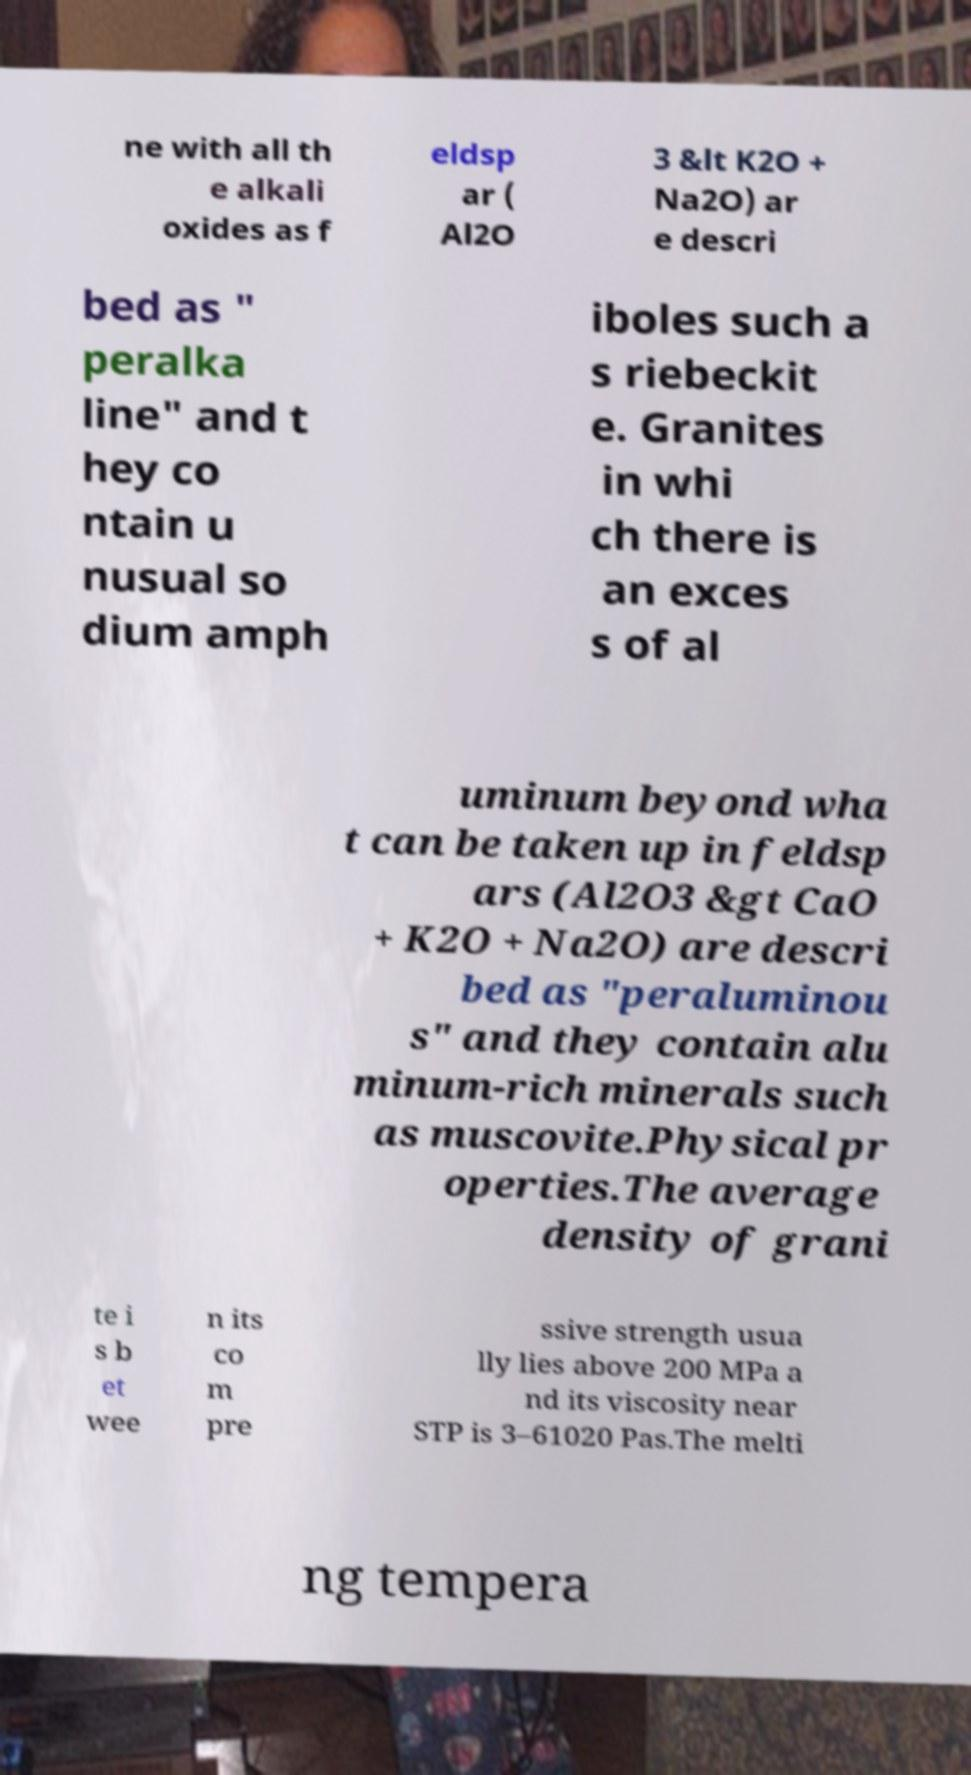I need the written content from this picture converted into text. Can you do that? ne with all th e alkali oxides as f eldsp ar ( Al2O 3 &lt K2O + Na2O) ar e descri bed as " peralka line" and t hey co ntain u nusual so dium amph iboles such a s riebeckit e. Granites in whi ch there is an exces s of al uminum beyond wha t can be taken up in feldsp ars (Al2O3 &gt CaO + K2O + Na2O) are descri bed as "peraluminou s" and they contain alu minum-rich minerals such as muscovite.Physical pr operties.The average density of grani te i s b et wee n its co m pre ssive strength usua lly lies above 200 MPa a nd its viscosity near STP is 3–61020 Pas.The melti ng tempera 